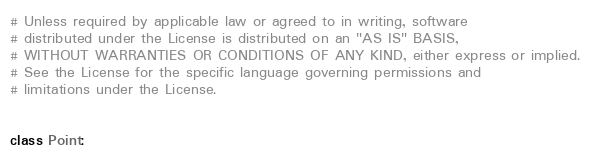Convert code to text. <code><loc_0><loc_0><loc_500><loc_500><_Python_># Unless required by applicable law or agreed to in writing, software
# distributed under the License is distributed on an "AS IS" BASIS,
# WITHOUT WARRANTIES OR CONDITIONS OF ANY KIND, either express or implied.
# See the License for the specific language governing permissions and
# limitations under the License.


class Point:</code> 